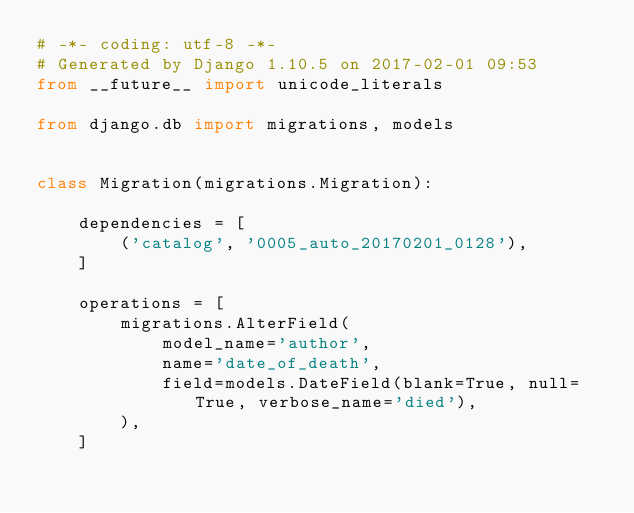Convert code to text. <code><loc_0><loc_0><loc_500><loc_500><_Python_># -*- coding: utf-8 -*-
# Generated by Django 1.10.5 on 2017-02-01 09:53
from __future__ import unicode_literals

from django.db import migrations, models


class Migration(migrations.Migration):

    dependencies = [
        ('catalog', '0005_auto_20170201_0128'),
    ]

    operations = [
        migrations.AlterField(
            model_name='author',
            name='date_of_death',
            field=models.DateField(blank=True, null=True, verbose_name='died'),
        ),
    ]
</code> 